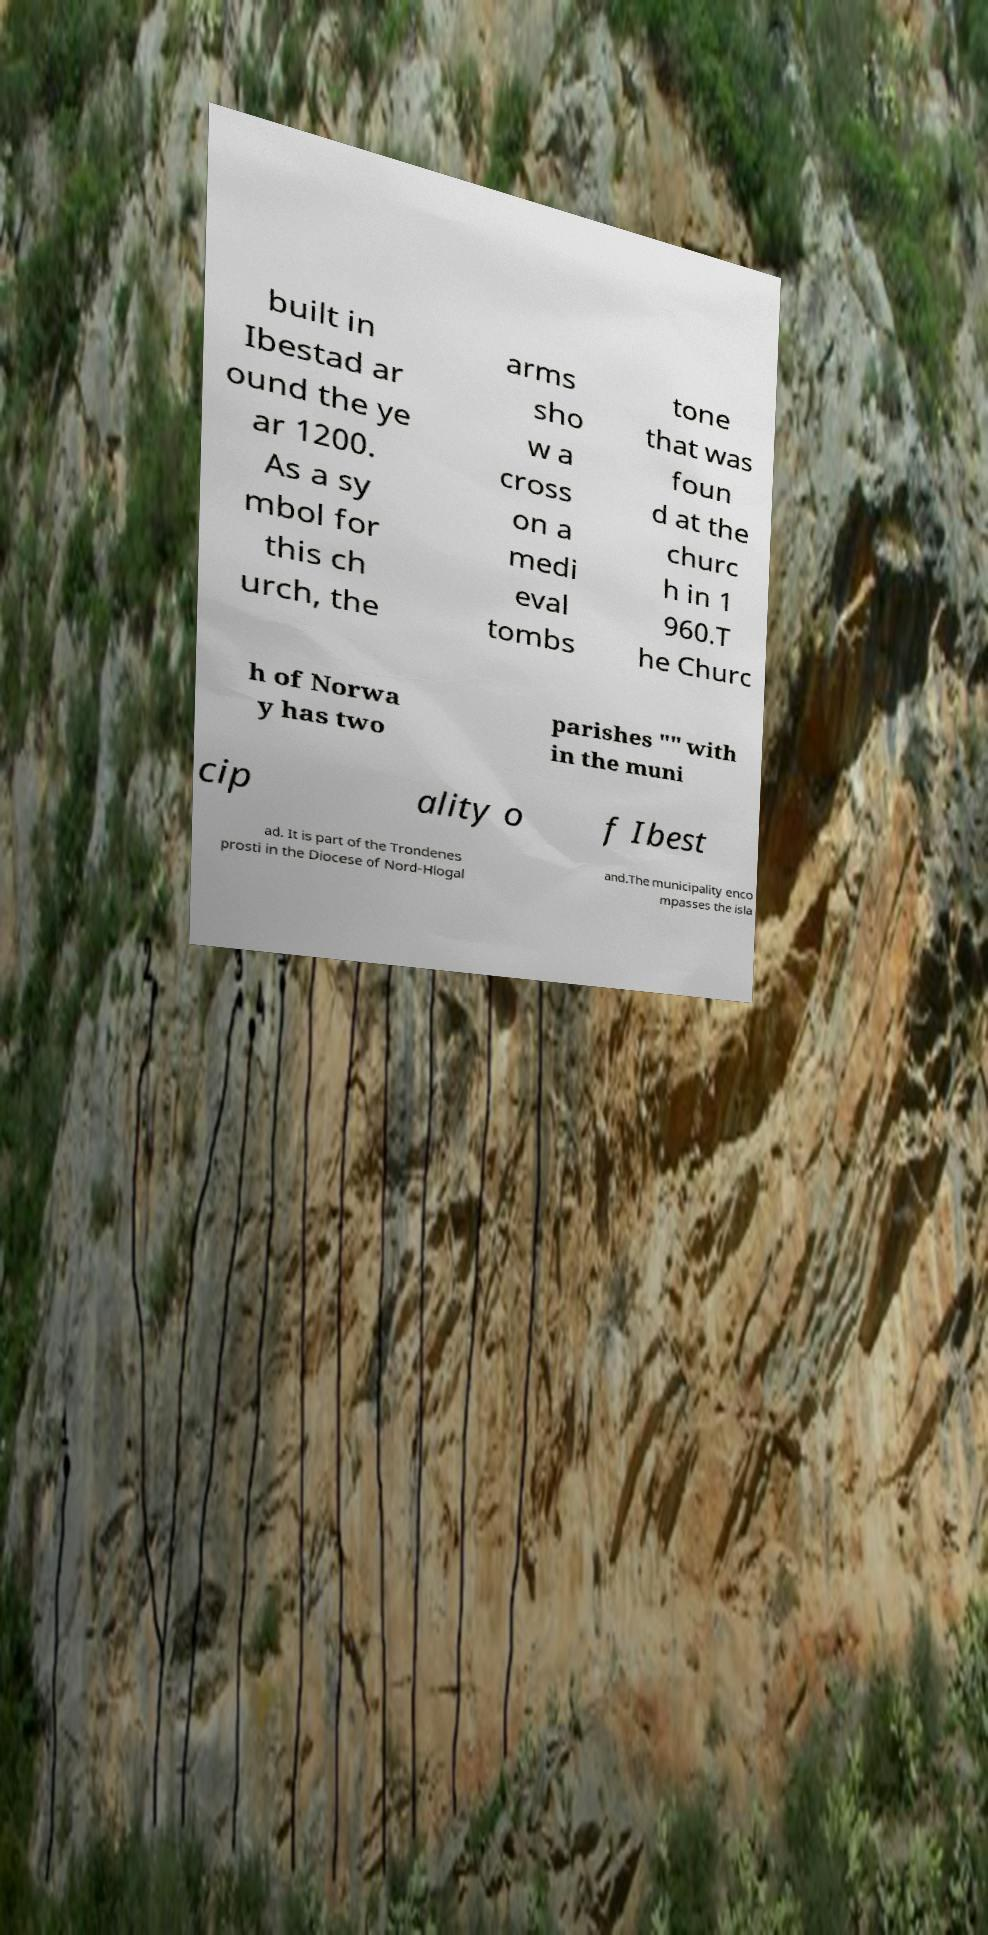Could you extract and type out the text from this image? built in Ibestad ar ound the ye ar 1200. As a sy mbol for this ch urch, the arms sho w a cross on a medi eval tombs tone that was foun d at the churc h in 1 960.T he Churc h of Norwa y has two parishes "" with in the muni cip ality o f Ibest ad. It is part of the Trondenes prosti in the Diocese of Nord-Hlogal and.The municipality enco mpasses the isla 